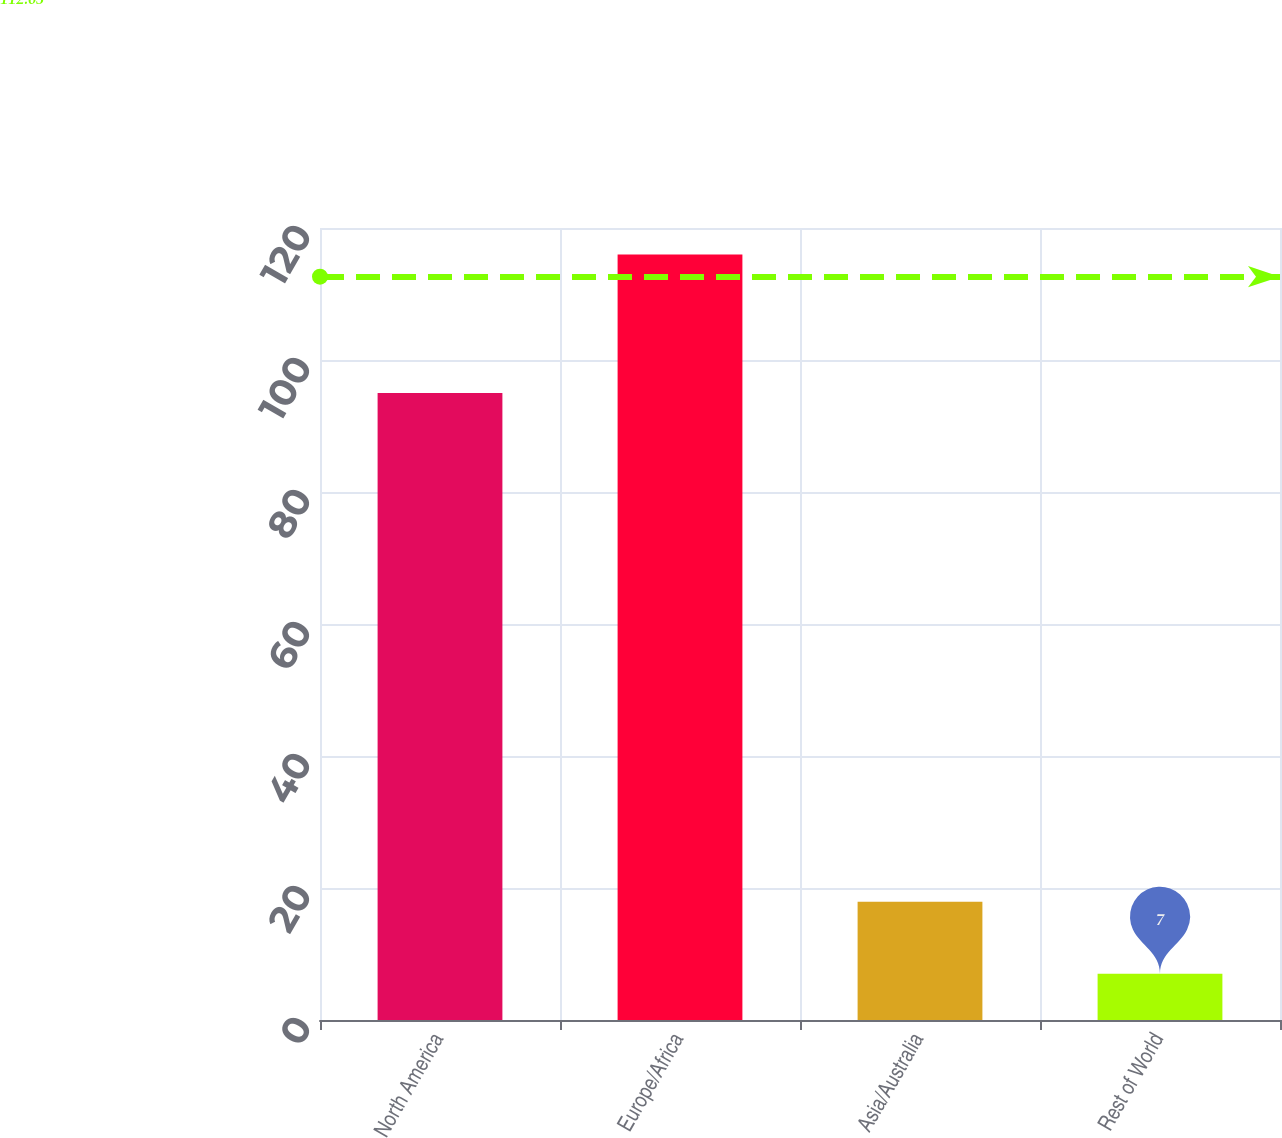Convert chart. <chart><loc_0><loc_0><loc_500><loc_500><bar_chart><fcel>North America<fcel>Europe/Africa<fcel>Asia/Australia<fcel>Rest of World<nl><fcel>95<fcel>116<fcel>17.9<fcel>7<nl></chart> 